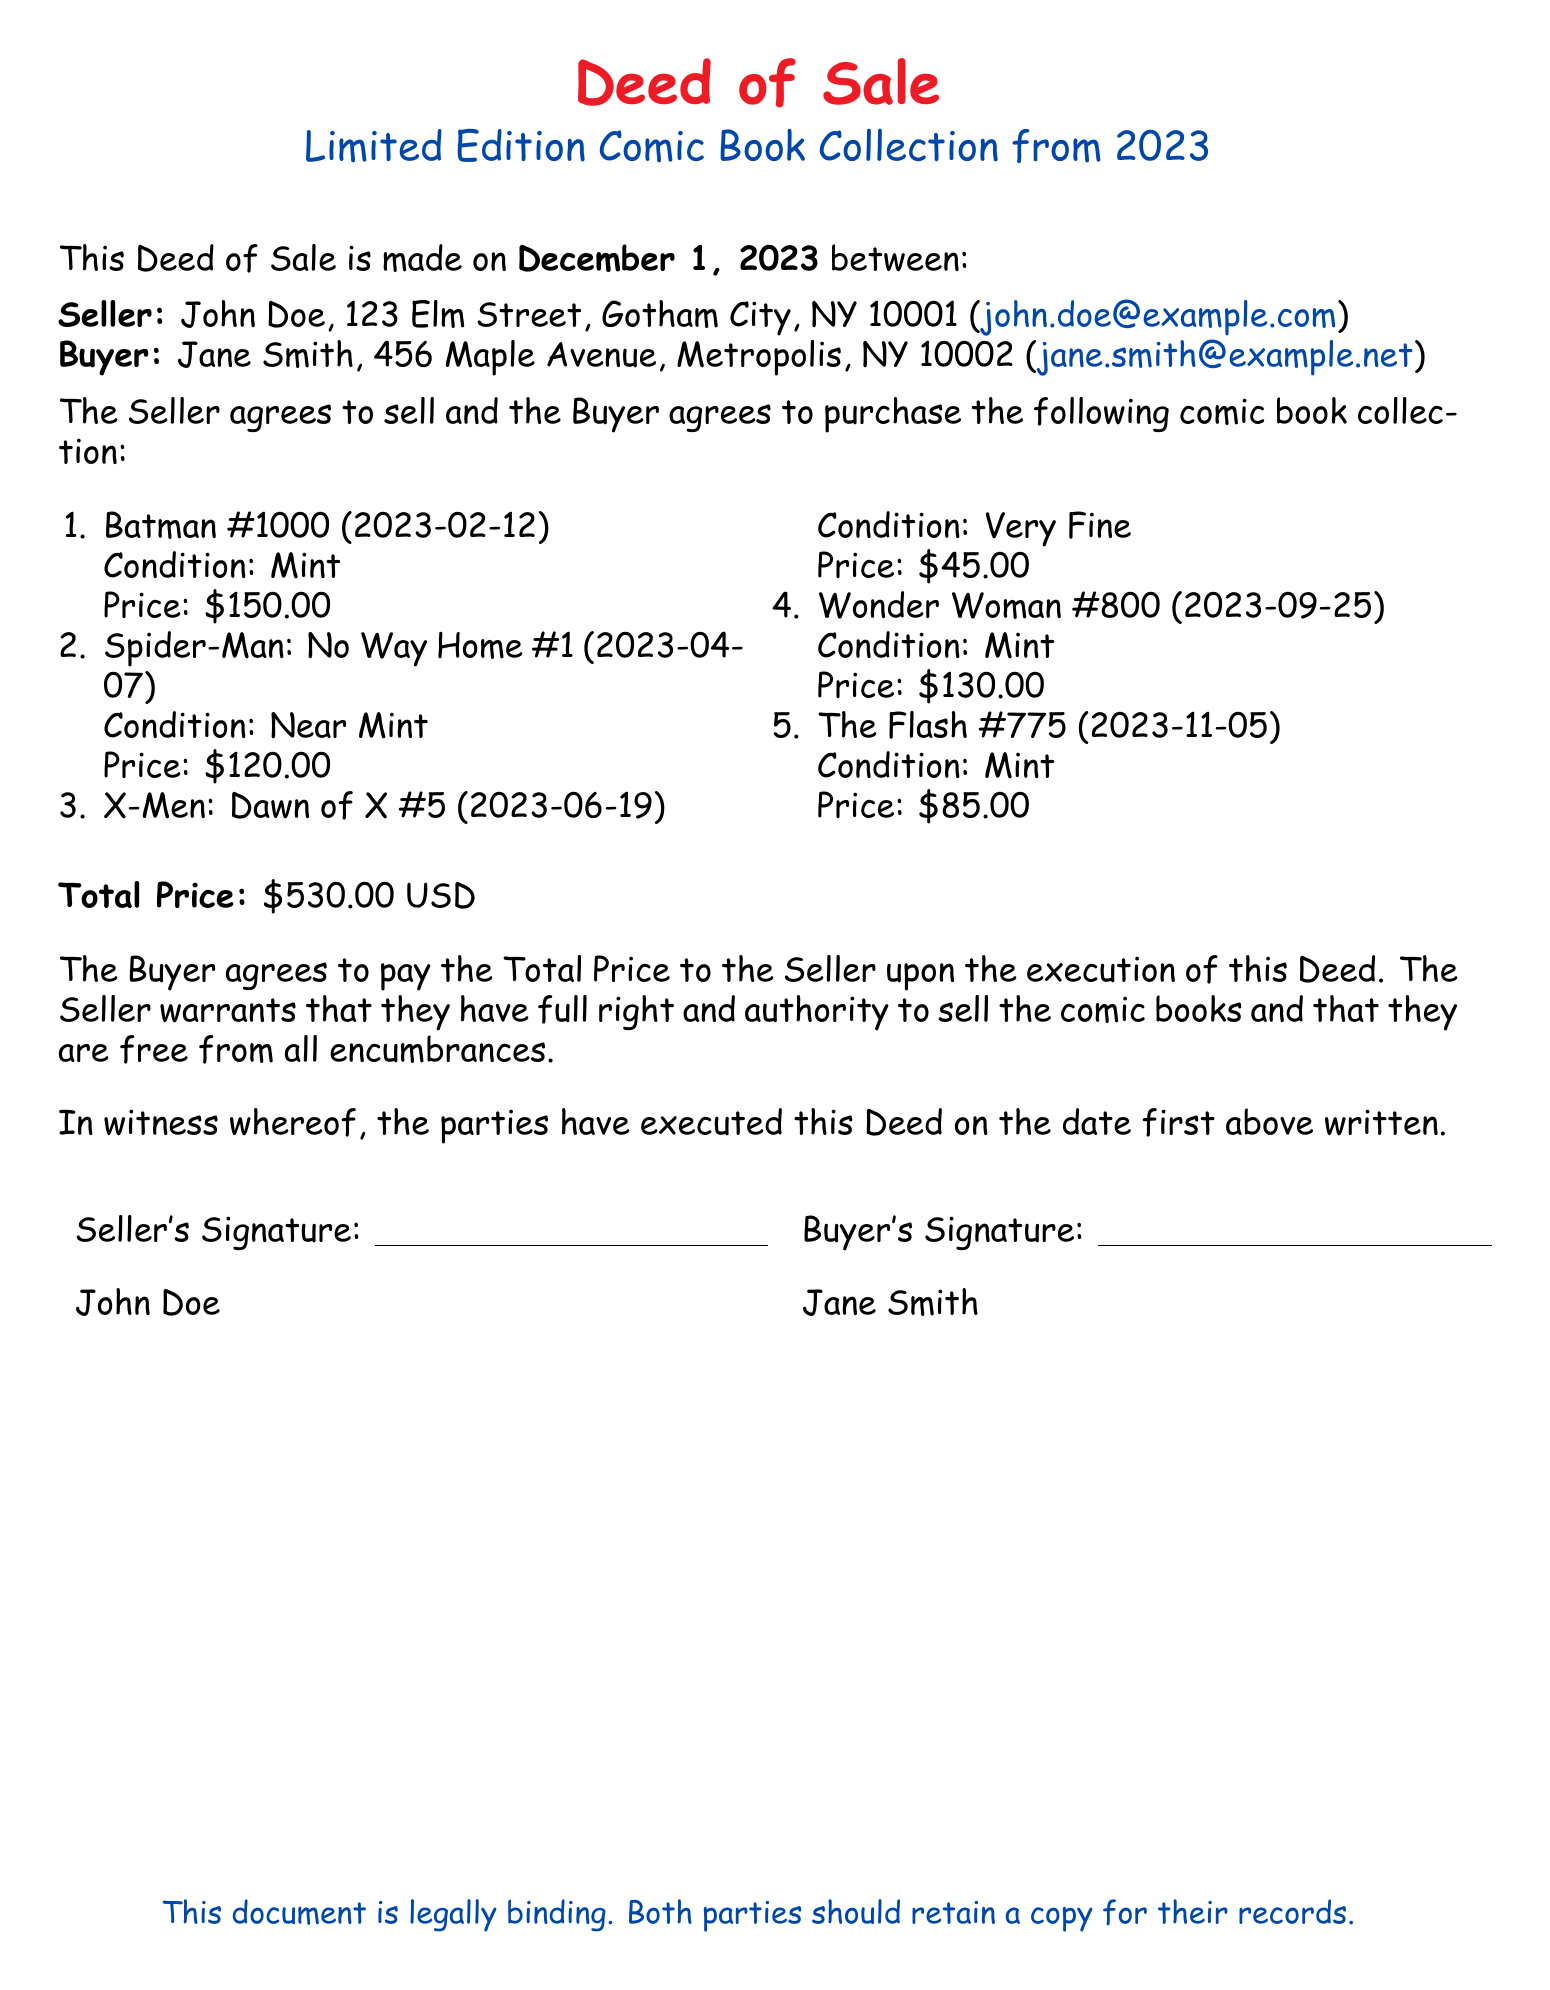What is the total price of the comic book collection? The total price is stated as the sum of all individual prices of the comic books listed in the document.
Answer: $530.00 USD Who is the seller? The seller's name is provided in the document, identifying the individual responsible for the sale.
Answer: John Doe What is the condition of Spider-Man: No Way Home #1? The condition is specified in the list of comic books included in the Deed of Sale.
Answer: Near Mint When was the Deed of Sale made? The date of the Deed is explicitly mentioned at the beginning of the document.
Answer: December 1, 2023 How many comic books are included in the sale? The number of comic books can be counted based on the enumeration in the document.
Answer: 5 What is the condition of Batman #1000? The condition is listed in the description of Batman #1000 in the document.
Answer: Mint What is the buyer's email address? The buyer's email address is included for identification and communication purposes in the document.
Answer: jane.smith@example.net What is stated about the seller's authority? This reference discusses the seller's right to sell the items, as detailed within the terms of the Deed.
Answer: Full right and authority to sell What is the address of the buyer? The address of the buyer is specified in the opening section of the document.
Answer: 456 Maple Avenue, Metropolis, NY 10002 